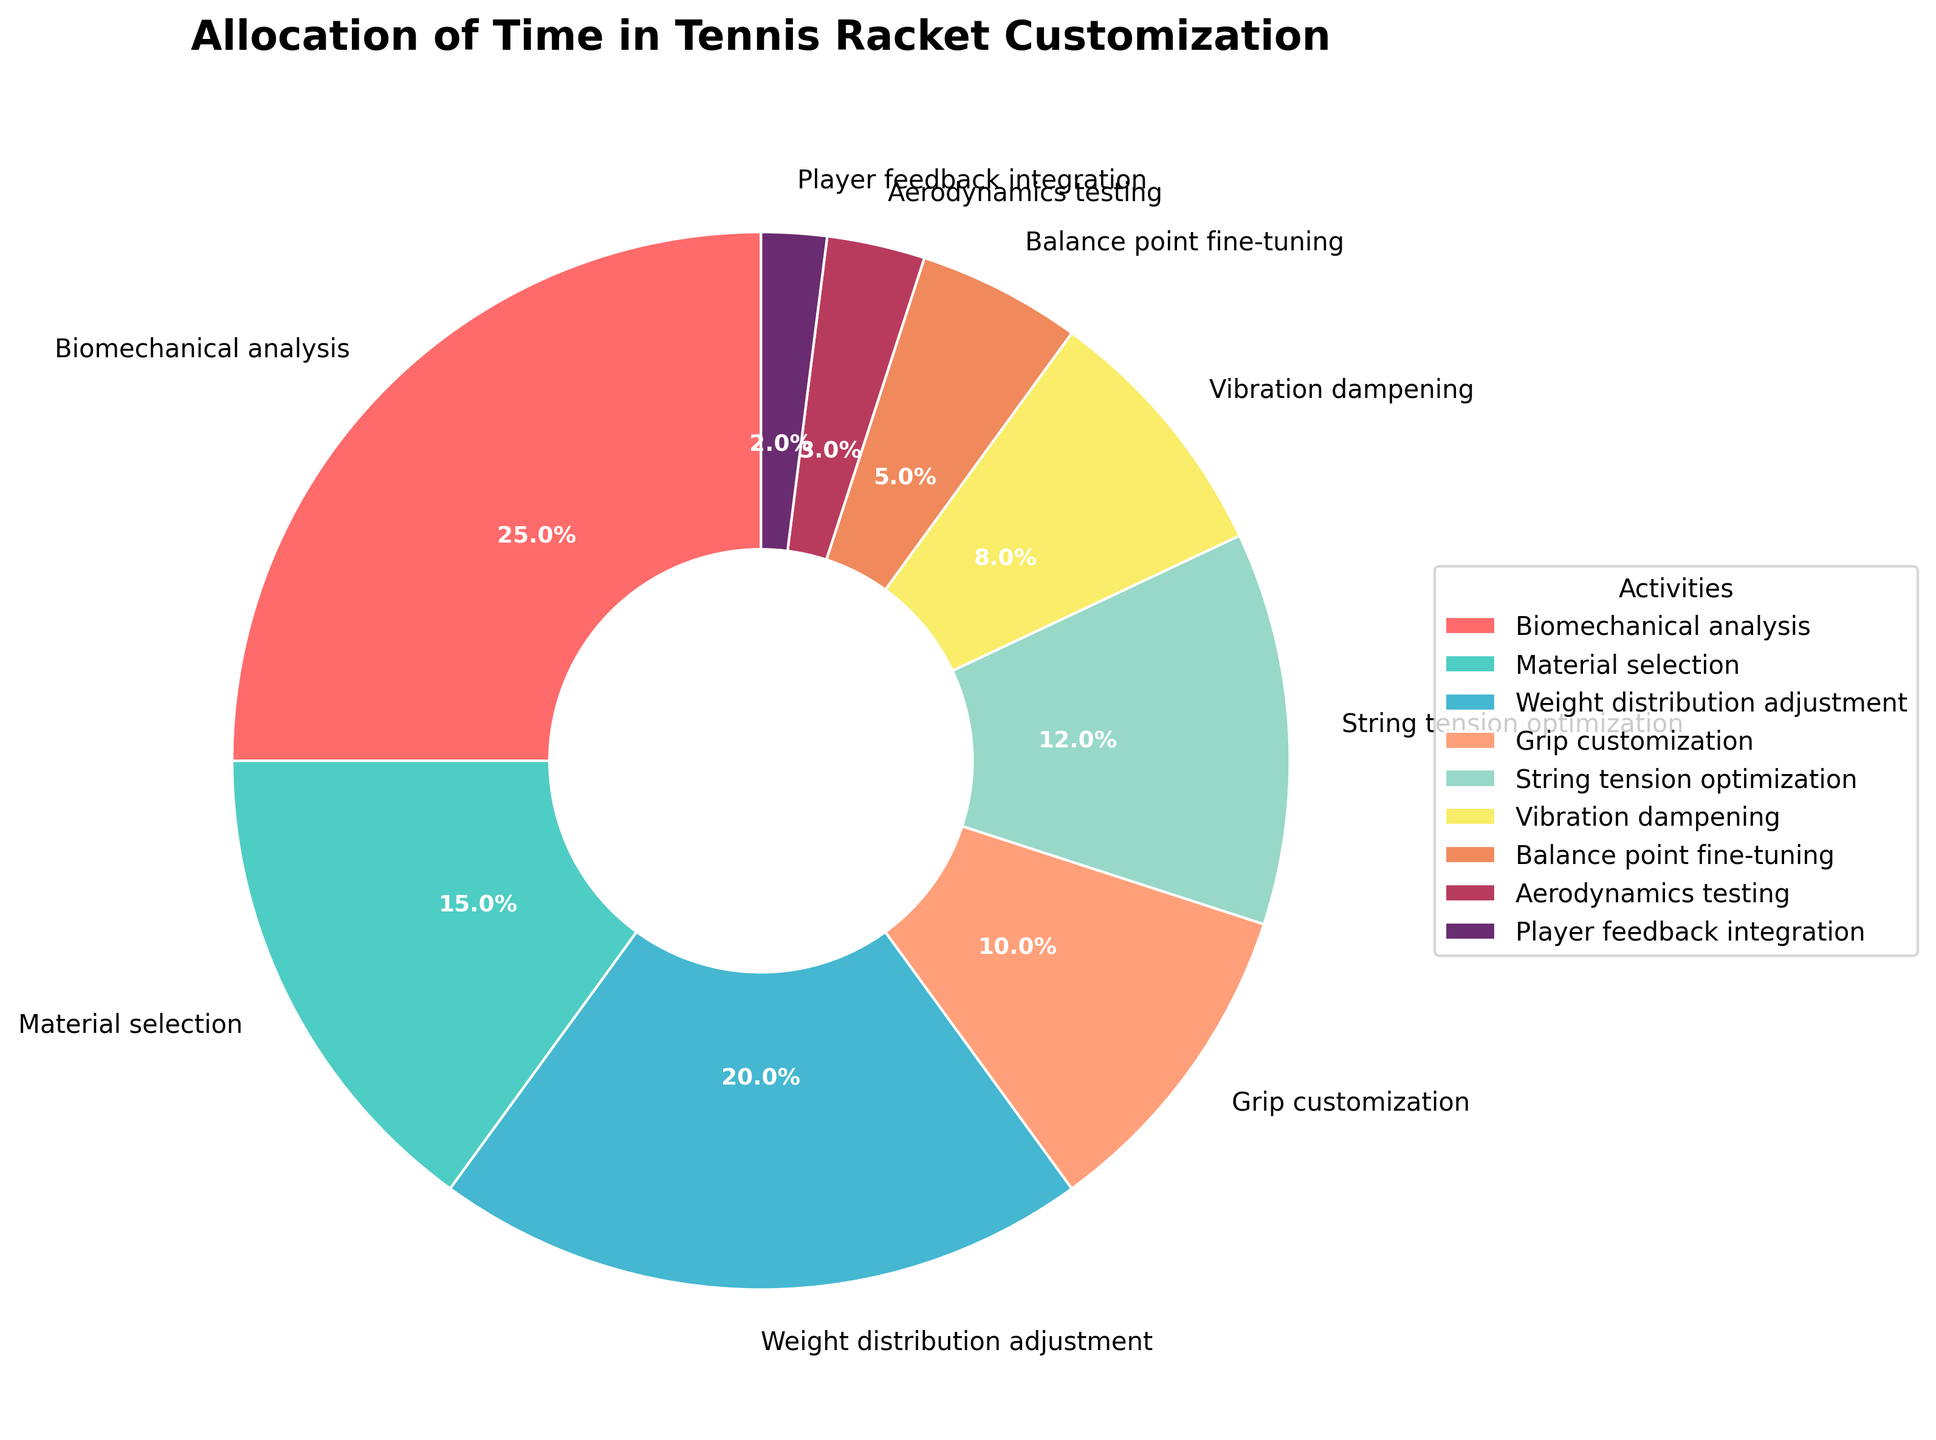How much more time is spent on biomechanical analysis compared to player feedback integration? First, identify the percentage spent on biomechanical analysis (25%) and player feedback integration (2%). Then subtract the two: 25 - 2 = 23.
Answer: 23% Which activity takes up the least proportion of time? By looking at the pie chart, identify that aerodynamics testing has the smallest slice of the pie, which corresponds to 3%.
Answer: Aerodynamics testing If we combine the time spent on weight distribution adjustment and string tension optimization, what is the total percentage? The percentages for weight distribution adjustment and string tension optimization are 20% and 12%, respectively. Adding them together: 20 + 12 = 32.
Answer: 32% What is the difference in the percentage of time spent on grip customization and vibration dampening? The percentage for grip customization is 10% and for vibration dampening is 8%. The difference is 10 - 8 = 2.
Answer: 2% Which activity takes up exactly twice the amount of time as grip customization? Grip customization takes 10%. Biomechanical analysis, which takes 25%, is not twice as much. Material selection at 15% is not either. However, weight distribution adjustment at 20% is exactly twice as much as grip customization (10% x 2 = 20%).
Answer: Weight distribution adjustment What percentage of time is allocated to the top three most time-consuming activities? The three top activities are biomechanical analysis (25%), weight distribution adjustment (20%), and material selection (15%). Adding them: 25 + 20 + 15 = 60.
Answer: 60% How does the time spent on material selection compare to that spent on balance point fine-tuning? Material selection takes 15% of the time, while balance point fine-tuning takes 5%. Material selection takes three times as much time: 15 ÷ 5 = 3.
Answer: Three times more Which two activities together account for the same percentage as biomechanical analysis alone? Biomechanical analysis accounts for 25%. Adding vibration dampening (8%) and string tension optimization (12%) gives 8 + 12 = 20, which is not equal. Adding weight distribution adjustment (20%) and player feedback integration (2%) gives 20 + 2 = 22, which is close but not exact. However, adding material selection (15%) and balance point fine-tuning (5%) gives 15 + 5 = 20. The correct combination is material selection and balance point fine-tuning, which gives 15 + 5 + 5 (grip customization) = 25%.
Answer: Material selection and grip customization Based on the colors, what color represents aerodynamics testing? Look for the smallest section in the pie chart, which is aerodynamics testing at 3%, and note its color.
Answer: Light purple 